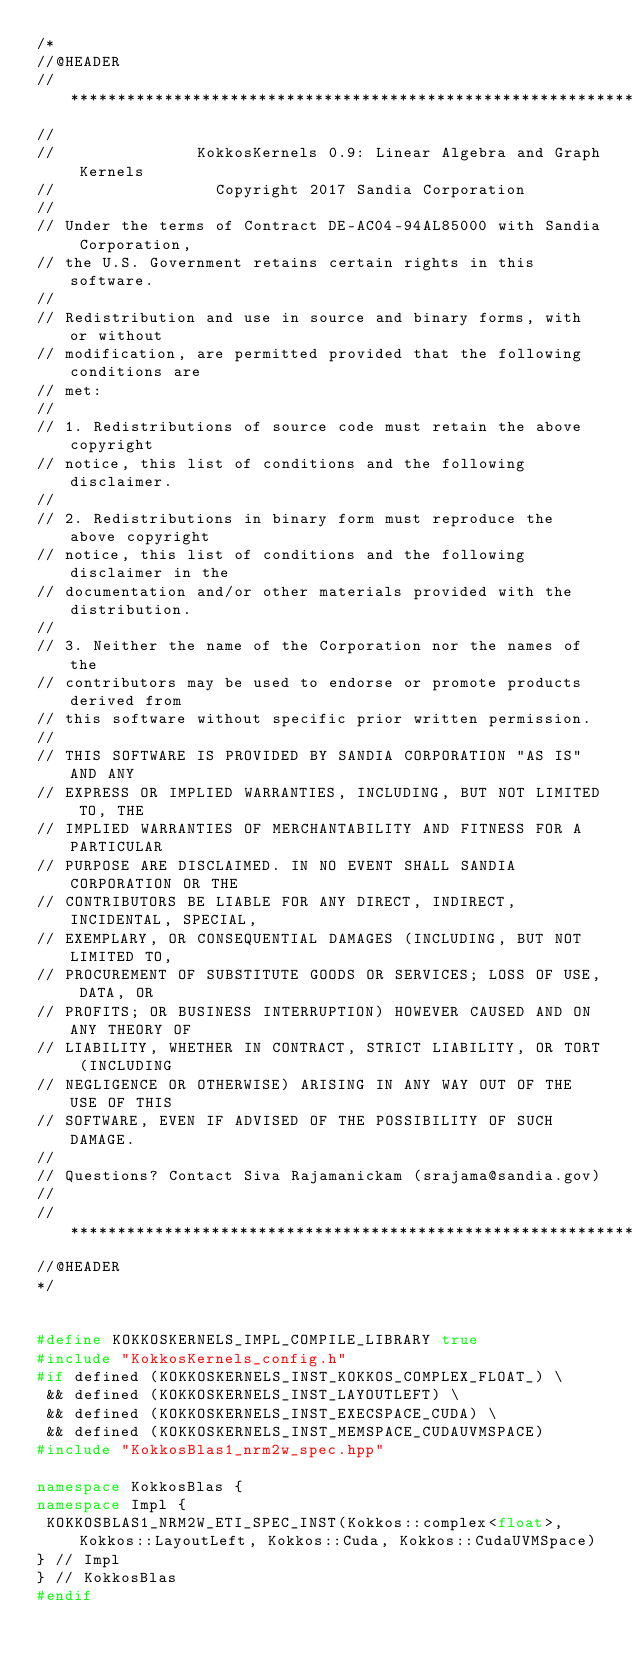Convert code to text. <code><loc_0><loc_0><loc_500><loc_500><_C++_>/*
//@HEADER
// ************************************************************************
//
//               KokkosKernels 0.9: Linear Algebra and Graph Kernels
//                 Copyright 2017 Sandia Corporation
//
// Under the terms of Contract DE-AC04-94AL85000 with Sandia Corporation,
// the U.S. Government retains certain rights in this software.
//
// Redistribution and use in source and binary forms, with or without
// modification, are permitted provided that the following conditions are
// met:
//
// 1. Redistributions of source code must retain the above copyright
// notice, this list of conditions and the following disclaimer.
//
// 2. Redistributions in binary form must reproduce the above copyright
// notice, this list of conditions and the following disclaimer in the
// documentation and/or other materials provided with the distribution.
//
// 3. Neither the name of the Corporation nor the names of the
// contributors may be used to endorse or promote products derived from
// this software without specific prior written permission.
//
// THIS SOFTWARE IS PROVIDED BY SANDIA CORPORATION "AS IS" AND ANY
// EXPRESS OR IMPLIED WARRANTIES, INCLUDING, BUT NOT LIMITED TO, THE
// IMPLIED WARRANTIES OF MERCHANTABILITY AND FITNESS FOR A PARTICULAR
// PURPOSE ARE DISCLAIMED. IN NO EVENT SHALL SANDIA CORPORATION OR THE
// CONTRIBUTORS BE LIABLE FOR ANY DIRECT, INDIRECT, INCIDENTAL, SPECIAL,
// EXEMPLARY, OR CONSEQUENTIAL DAMAGES (INCLUDING, BUT NOT LIMITED TO,
// PROCUREMENT OF SUBSTITUTE GOODS OR SERVICES; LOSS OF USE, DATA, OR
// PROFITS; OR BUSINESS INTERRUPTION) HOWEVER CAUSED AND ON ANY THEORY OF
// LIABILITY, WHETHER IN CONTRACT, STRICT LIABILITY, OR TORT (INCLUDING
// NEGLIGENCE OR OTHERWISE) ARISING IN ANY WAY OUT OF THE USE OF THIS
// SOFTWARE, EVEN IF ADVISED OF THE POSSIBILITY OF SUCH DAMAGE.
//
// Questions? Contact Siva Rajamanickam (srajama@sandia.gov)
//
// ************************************************************************
//@HEADER
*/


#define KOKKOSKERNELS_IMPL_COMPILE_LIBRARY true
#include "KokkosKernels_config.h"
#if defined (KOKKOSKERNELS_INST_KOKKOS_COMPLEX_FLOAT_) \
 && defined (KOKKOSKERNELS_INST_LAYOUTLEFT) \
 && defined (KOKKOSKERNELS_INST_EXECSPACE_CUDA) \
 && defined (KOKKOSKERNELS_INST_MEMSPACE_CUDAUVMSPACE)
#include "KokkosBlas1_nrm2w_spec.hpp"

namespace KokkosBlas {
namespace Impl {
 KOKKOSBLAS1_NRM2W_ETI_SPEC_INST(Kokkos::complex<float>, Kokkos::LayoutLeft, Kokkos::Cuda, Kokkos::CudaUVMSpace)
} // Impl
} // KokkosBlas
#endif
</code> 